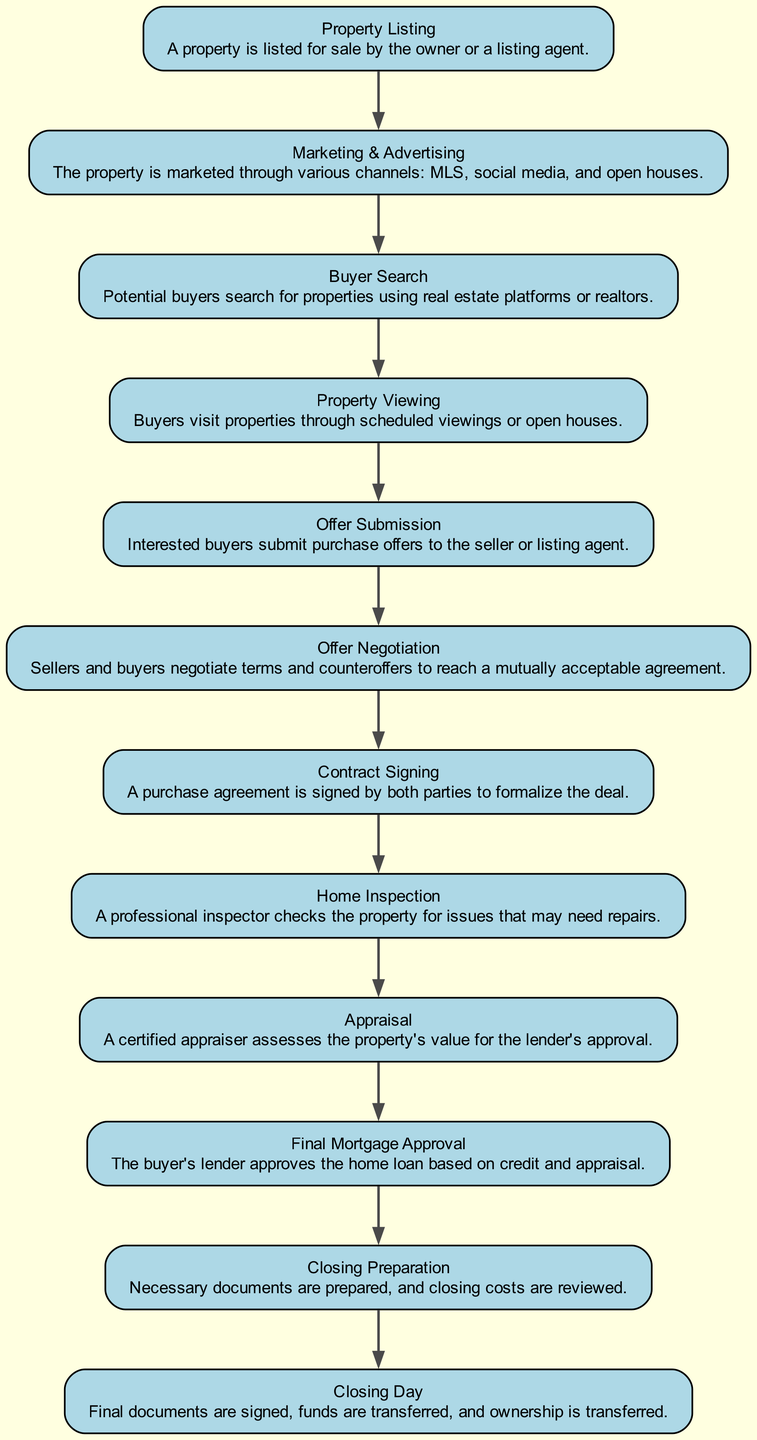What is the first node in the diagram? The first node in the diagram is labeled "Property Listing." This can be determined by looking at the sequential arrangement of nodes from top to bottom.
Answer: Property Listing How many nodes are in the diagram? By counting the individual nodes listed in the elements of the diagram, we find there are twelve nodes.
Answer: 12 What is the last step before "Closing Day"? The node just before "Closing Day" is "Closing Preparation." This can be derived by tracing the steps leading to the last node in the chain.
Answer: Closing Preparation Which node involves buyers viewing properties? The node that involves buyers viewing properties is "Property Viewing." This is evident from the description associated with that specific node.
Answer: Property Viewing What process occurs after "Offer Submission"? The process that follows "Offer Submission" is "Offer Negotiation." This can be identified by looking at the flow of the diagram, where each step leads to the next directly.
Answer: Offer Negotiation How many interactions occur between buyers and sellers in the diagram? There are two main interactions between buyers and sellers in the diagram: "Offer Submission" and "Offer Negotiation." These nodes indicate direct communication between the parties.
Answer: 2 What is the significance of "Home Inspection" in the process? "Home Inspection" is significant as it ensures any issues with the property are identified before finalizing the purchase. The node follows important steps such as "Contract Signing."
Answer: Identifies property issues Which node comes immediately after "Final Mortgage Approval"? The node that comes immediately after "Final Mortgage Approval" is "Closing Preparation." This can be seen by following the flow from one node to the next.
Answer: Closing Preparation What are the initial stages of the real estate purchase process? The initial stages are "Property Listing," "Marketing & Advertising," and "Buyer Search." This can be found by reviewing the first few nodes in the flow of the diagram.
Answer: Property Listing, Marketing & Advertising, Buyer Search 